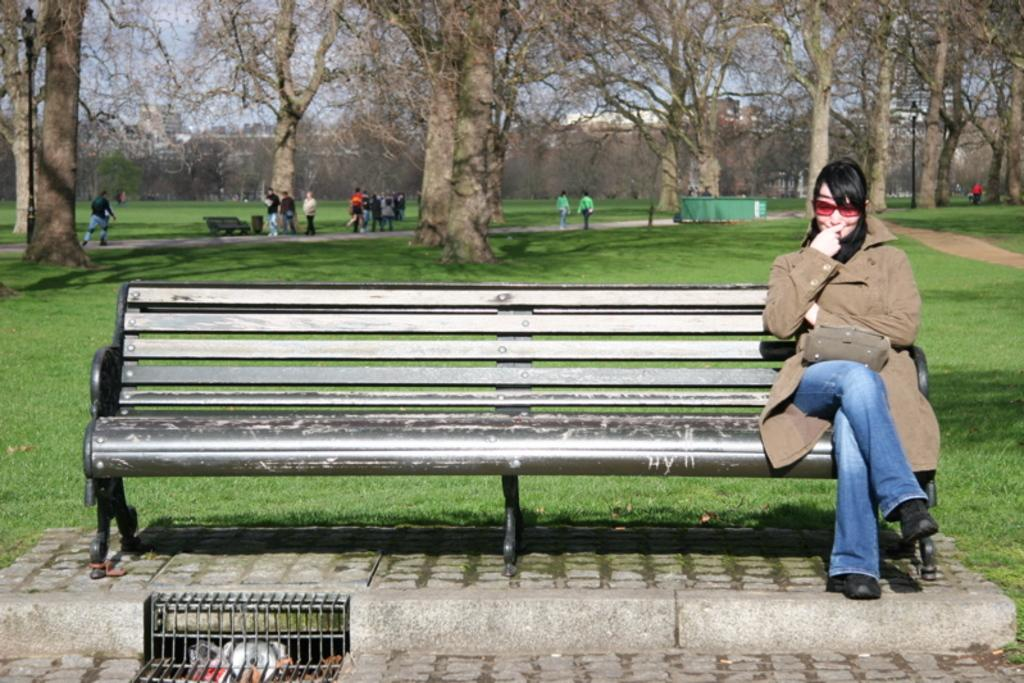What type of vegetation can be seen in the distance in the image? There are bare trees in the distance in the image. What is the ground like where the people are standing? The people are standing on a grassy area. How many benches are visible in the image? There are two benches in the image. What is the woman on one of the benches doing? The woman is sitting on one of the benches. What accessories is the woman wearing? The woman is wearing goggles and a jacket. What object is the woman holding? The woman is holding a bag. What type of cabbage is the duck eating in the image? There is no cabbage or duck present in the image. What type of drug is the woman using while sitting on the bench? There is no drug use depicted in the image; the woman is simply sitting on the bench wearing goggles and holding a bag. 